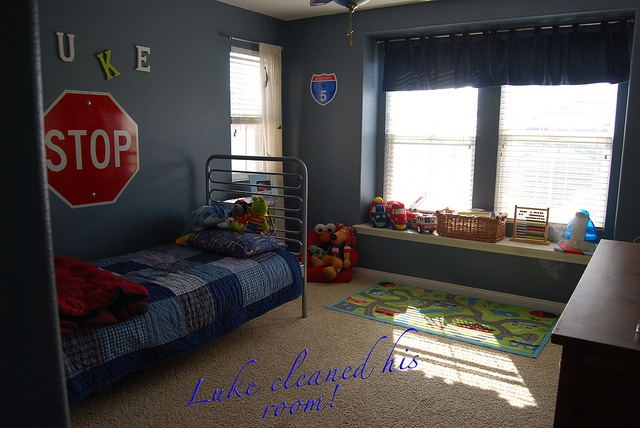Describe the objects in this image and their specific colors. I can see bed in black, gray, navy, and maroon tones, stop sign in black, maroon, gray, and brown tones, teddy bear in black, maroon, and gray tones, and teddy bear in black, maroon, and gray tones in this image. 